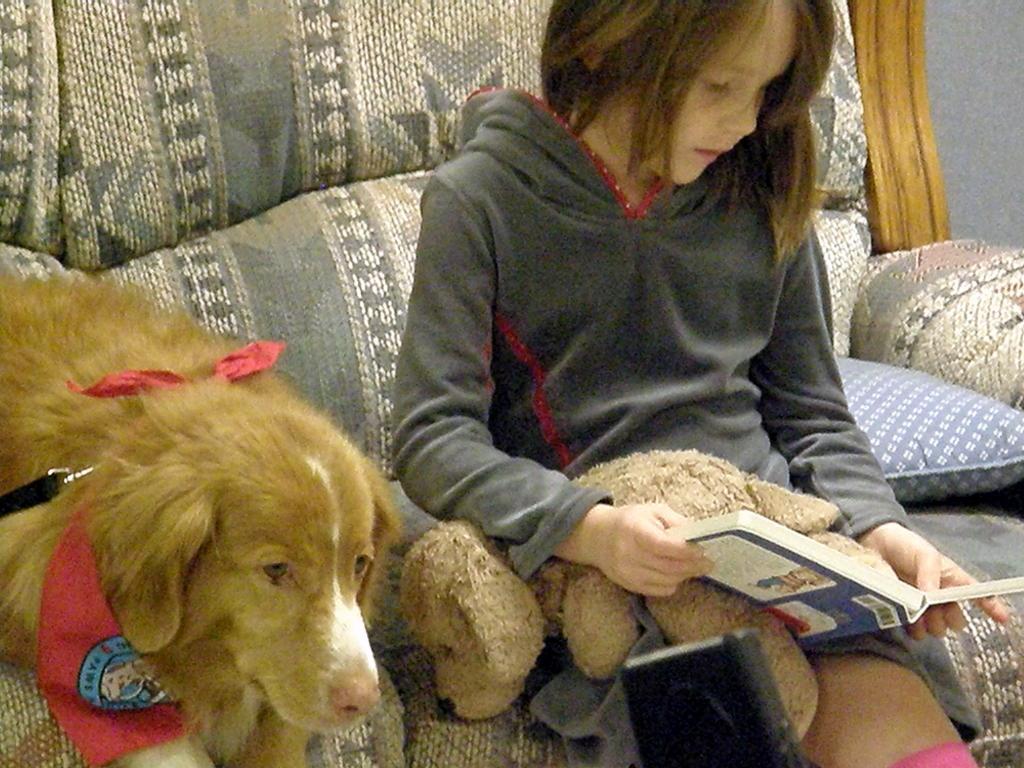In one or two sentences, can you explain what this image depicts? A girl is sitting in a sofa. She has a toy on her lap. She is reading a book. There is a dog sitting beside her. 